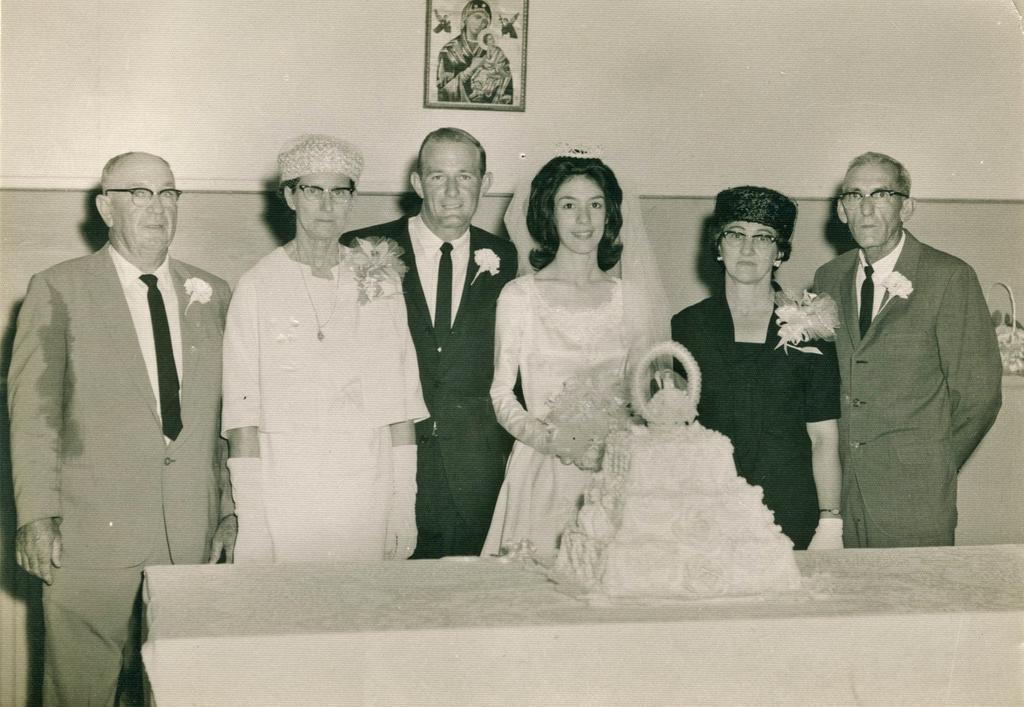Can you describe this image briefly? This is a black and white picture, in this image we can see a few people standing, in front of them, we can see a table, on the table there is a cake, in the background we can see a photo frame on the wall. 